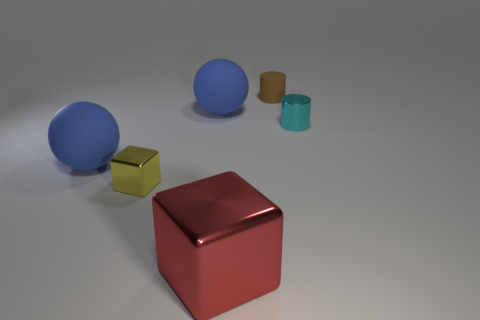Add 2 rubber cylinders. How many objects exist? 8 Subtract all balls. How many objects are left? 4 Add 5 cyan cylinders. How many cyan cylinders are left? 6 Add 1 big metallic things. How many big metallic things exist? 2 Subtract 1 brown cylinders. How many objects are left? 5 Subtract all cyan objects. Subtract all large yellow matte objects. How many objects are left? 5 